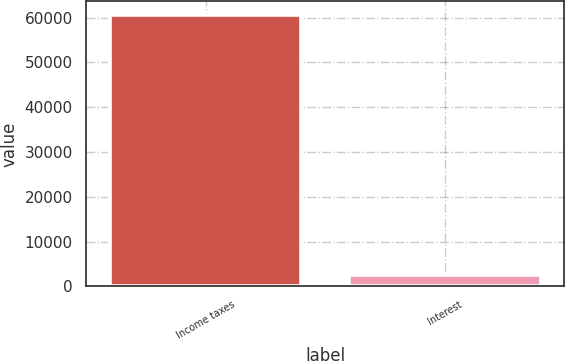<chart> <loc_0><loc_0><loc_500><loc_500><bar_chart><fcel>Income taxes<fcel>Interest<nl><fcel>60609<fcel>2502<nl></chart> 